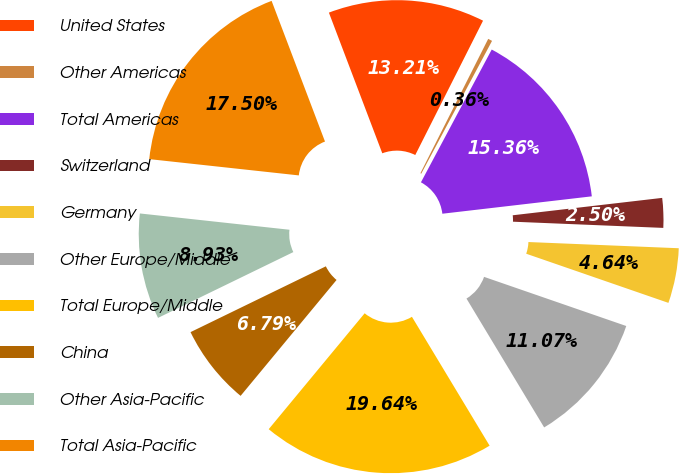Convert chart. <chart><loc_0><loc_0><loc_500><loc_500><pie_chart><fcel>United States<fcel>Other Americas<fcel>Total Americas<fcel>Switzerland<fcel>Germany<fcel>Other Europe/Middle<fcel>Total Europe/Middle<fcel>China<fcel>Other Asia-Pacific<fcel>Total Asia-Pacific<nl><fcel>13.21%<fcel>0.36%<fcel>15.36%<fcel>2.5%<fcel>4.64%<fcel>11.07%<fcel>19.64%<fcel>6.79%<fcel>8.93%<fcel>17.5%<nl></chart> 